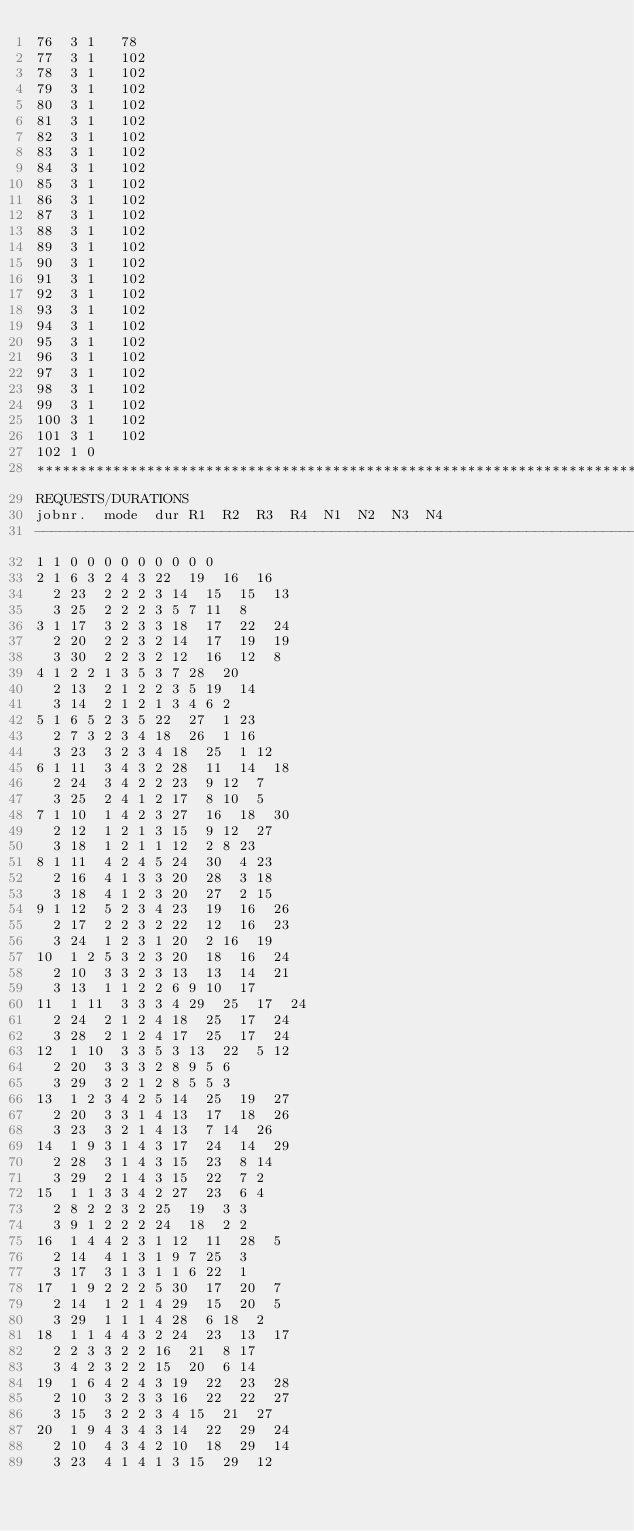Convert code to text. <code><loc_0><loc_0><loc_500><loc_500><_ObjectiveC_>76	3	1		78 
77	3	1		102 
78	3	1		102 
79	3	1		102 
80	3	1		102 
81	3	1		102 
82	3	1		102 
83	3	1		102 
84	3	1		102 
85	3	1		102 
86	3	1		102 
87	3	1		102 
88	3	1		102 
89	3	1		102 
90	3	1		102 
91	3	1		102 
92	3	1		102 
93	3	1		102 
94	3	1		102 
95	3	1		102 
96	3	1		102 
97	3	1		102 
98	3	1		102 
99	3	1		102 
100	3	1		102 
101	3	1		102 
102	1	0		
************************************************************************
REQUESTS/DURATIONS
jobnr.	mode	dur	R1	R2	R3	R4	N1	N2	N3	N4	
------------------------------------------------------------------------
1	1	0	0	0	0	0	0	0	0	0	
2	1	6	3	2	4	3	22	19	16	16	
	2	23	2	2	2	3	14	15	15	13	
	3	25	2	2	2	3	5	7	11	8	
3	1	17	3	2	3	3	18	17	22	24	
	2	20	2	2	3	2	14	17	19	19	
	3	30	2	2	3	2	12	16	12	8	
4	1	2	2	1	3	5	3	7	28	20	
	2	13	2	1	2	2	3	5	19	14	
	3	14	2	1	2	1	3	4	6	2	
5	1	6	5	2	3	5	22	27	1	23	
	2	7	3	2	3	4	18	26	1	16	
	3	23	3	2	3	4	18	25	1	12	
6	1	11	3	4	3	2	28	11	14	18	
	2	24	3	4	2	2	23	9	12	7	
	3	25	2	4	1	2	17	8	10	5	
7	1	10	1	4	2	3	27	16	18	30	
	2	12	1	2	1	3	15	9	12	27	
	3	18	1	2	1	1	12	2	8	23	
8	1	11	4	2	4	5	24	30	4	23	
	2	16	4	1	3	3	20	28	3	18	
	3	18	4	1	2	3	20	27	2	15	
9	1	12	5	2	3	4	23	19	16	26	
	2	17	2	2	3	2	22	12	16	23	
	3	24	1	2	3	1	20	2	16	19	
10	1	2	5	3	2	3	20	18	16	24	
	2	10	3	3	2	3	13	13	14	21	
	3	13	1	1	2	2	6	9	10	17	
11	1	11	3	3	3	4	29	25	17	24	
	2	24	2	1	2	4	18	25	17	24	
	3	28	2	1	2	4	17	25	17	24	
12	1	10	3	3	5	3	13	22	5	12	
	2	20	3	3	3	2	8	9	5	6	
	3	29	3	2	1	2	8	5	5	3	
13	1	2	3	4	2	5	14	25	19	27	
	2	20	3	3	1	4	13	17	18	26	
	3	23	3	2	1	4	13	7	14	26	
14	1	9	3	1	4	3	17	24	14	29	
	2	28	3	1	4	3	15	23	8	14	
	3	29	2	1	4	3	15	22	7	2	
15	1	1	3	3	4	2	27	23	6	4	
	2	8	2	2	3	2	25	19	3	3	
	3	9	1	2	2	2	24	18	2	2	
16	1	4	4	2	3	1	12	11	28	5	
	2	14	4	1	3	1	9	7	25	3	
	3	17	3	1	3	1	1	6	22	1	
17	1	9	2	2	2	5	30	17	20	7	
	2	14	1	2	1	4	29	15	20	5	
	3	29	1	1	1	4	28	6	18	2	
18	1	1	4	4	3	2	24	23	13	17	
	2	2	3	3	2	2	16	21	8	17	
	3	4	2	3	2	2	15	20	6	14	
19	1	6	4	2	4	3	19	22	23	28	
	2	10	3	2	3	3	16	22	22	27	
	3	15	3	2	2	3	4	15	21	27	
20	1	9	4	3	4	3	14	22	29	24	
	2	10	4	3	4	2	10	18	29	14	
	3	23	4	1	4	1	3	15	29	12	</code> 